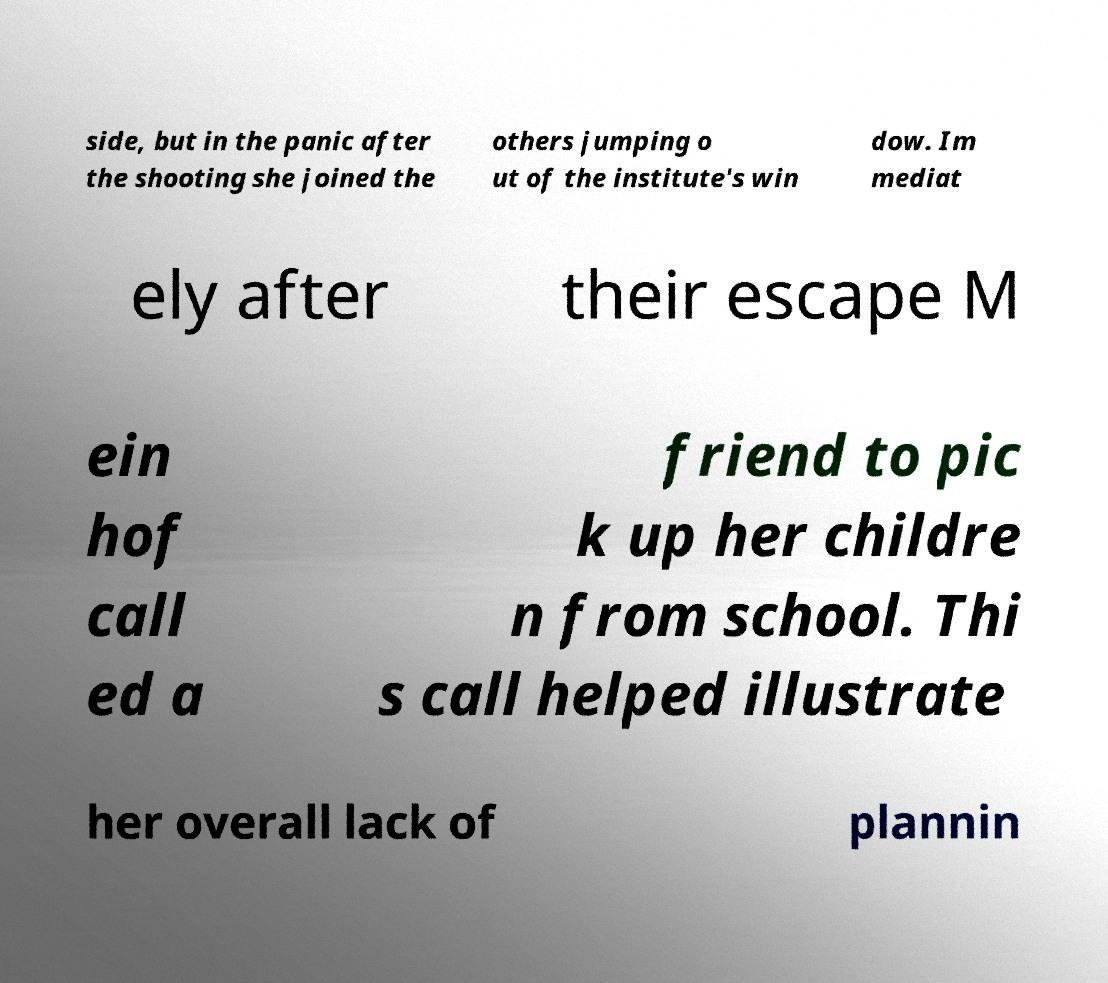Could you assist in decoding the text presented in this image and type it out clearly? side, but in the panic after the shooting she joined the others jumping o ut of the institute's win dow. Im mediat ely after their escape M ein hof call ed a friend to pic k up her childre n from school. Thi s call helped illustrate her overall lack of plannin 